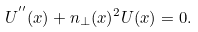Convert formula to latex. <formula><loc_0><loc_0><loc_500><loc_500>U ^ { ^ { \prime \prime } } ( x ) + n _ { \perp } ( x ) ^ { 2 } U ( x ) = 0 .</formula> 